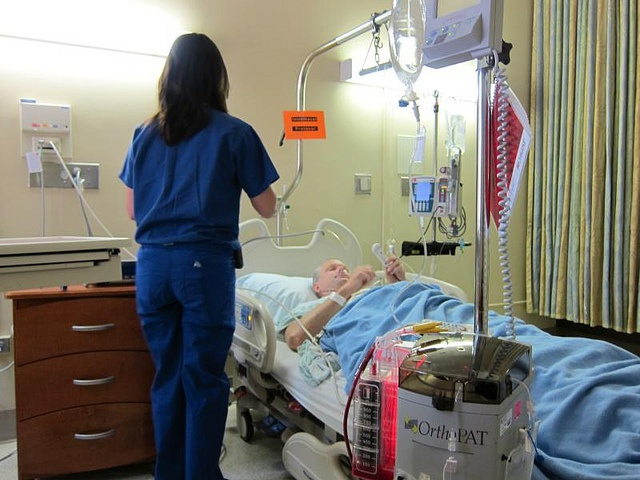Describe the objects in this image and their specific colors. I can see people in white, black, navy, gray, and darkgray tones, bed in white, darkgray, gray, lightgray, and lightblue tones, people in white, darkgray, gray, and tan tones, and remote in white, darkgray, tan, and lightgray tones in this image. 